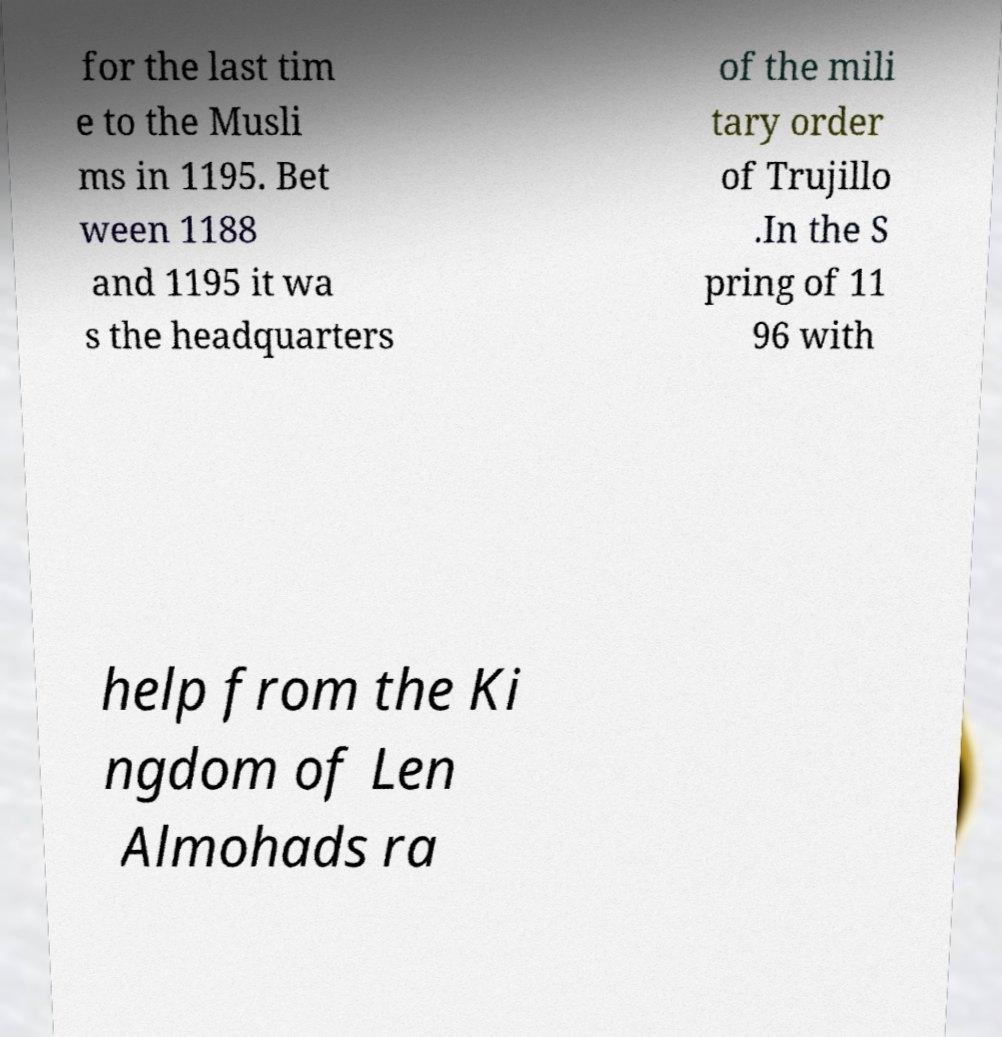Could you assist in decoding the text presented in this image and type it out clearly? for the last tim e to the Musli ms in 1195. Bet ween 1188 and 1195 it wa s the headquarters of the mili tary order of Trujillo .In the S pring of 11 96 with help from the Ki ngdom of Len Almohads ra 